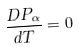Convert formula to latex. <formula><loc_0><loc_0><loc_500><loc_500>\frac { D P _ { \alpha } } { d T } = 0</formula> 